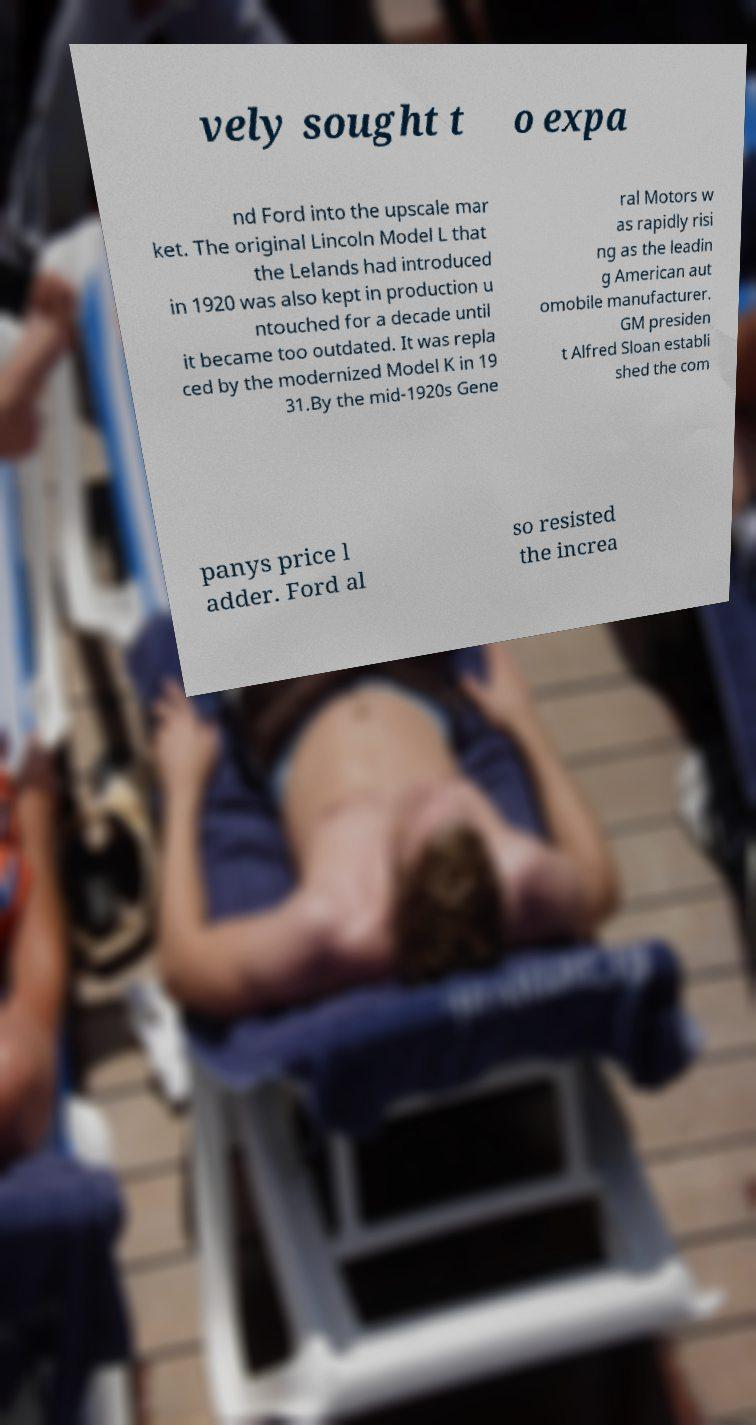Could you extract and type out the text from this image? vely sought t o expa nd Ford into the upscale mar ket. The original Lincoln Model L that the Lelands had introduced in 1920 was also kept in production u ntouched for a decade until it became too outdated. It was repla ced by the modernized Model K in 19 31.By the mid-1920s Gene ral Motors w as rapidly risi ng as the leadin g American aut omobile manufacturer. GM presiden t Alfred Sloan establi shed the com panys price l adder. Ford al so resisted the increa 